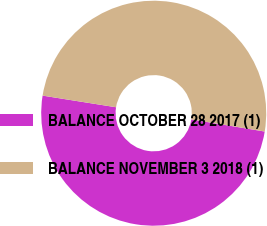<chart> <loc_0><loc_0><loc_500><loc_500><pie_chart><fcel>BALANCE OCTOBER 28 2017 (1)<fcel>BALANCE NOVEMBER 3 2018 (1)<nl><fcel>49.9%<fcel>50.1%<nl></chart> 